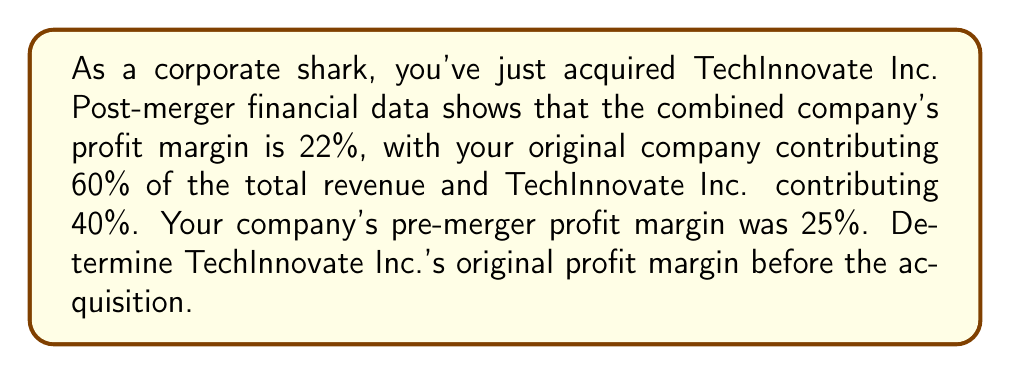Solve this math problem. Let's approach this step-by-step:

1) Let $x$ be TechInnovate Inc.'s original profit margin (as a decimal).

2) We know that the combined profit margin is a weighted average of the two companies' profit margins. We can express this as:

   $$(0.60 \times 0.25) + (0.40 \times x) = 0.22$$

3) Let's solve this equation:
   
   $$0.15 + 0.40x = 0.22$$

4) Subtract 0.15 from both sides:
   
   $$0.40x = 0.07$$

5) Divide both sides by 0.40:
   
   $$x = \frac{0.07}{0.40} = 0.175$$

6) Convert the decimal to a percentage:
   
   $$0.175 \times 100\% = 17.5\%$$

Therefore, TechInnovate Inc.'s original profit margin before the acquisition was 17.5%.
Answer: 17.5% 